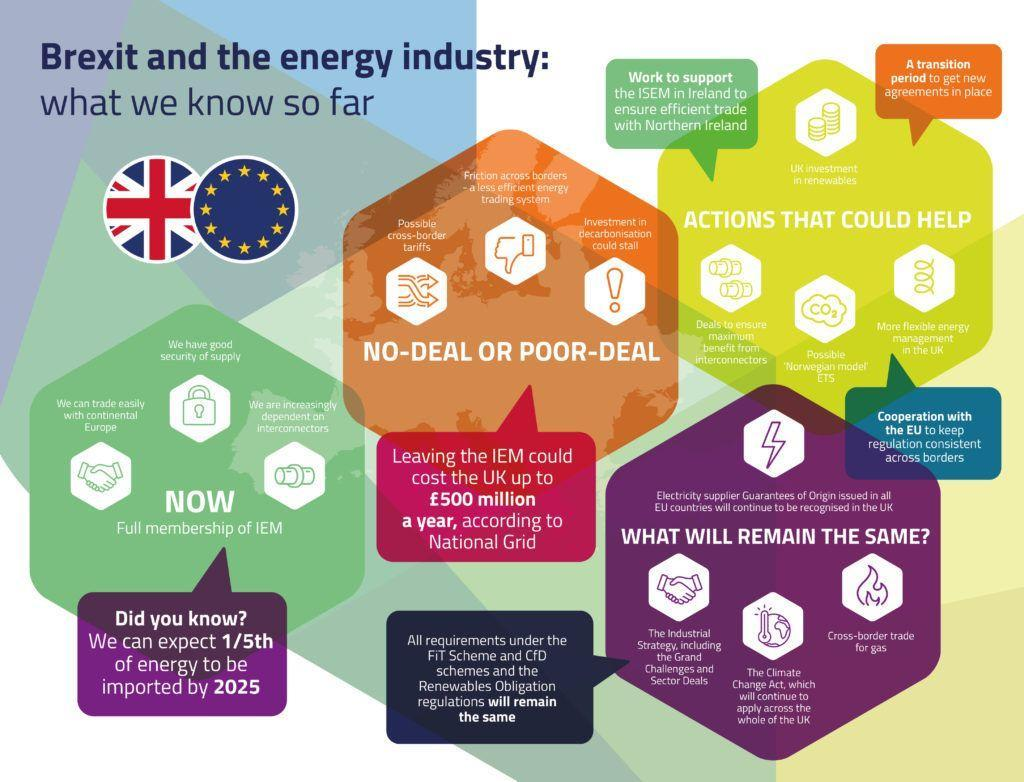What is represented by the symbol of fire ?
Answer the question with a short phrase. Cross-border trade for gas How many flags are shown here ? 2 Which Act shall remain the same for UK after Brexit ? The Climate Change Act To which region does the flag containing stars belong- UK, EU or America? EU How many small hexagons are there in the image of each big hexagon ? 3 How many images of big hexagons are shown here ? 4 What loss would UK incur per year while leaving the IEM ( in pounds) ? 500 million What is the colour of the hexagon that says "what will remain the same?" - purple, white, red or yellow ? Purple 